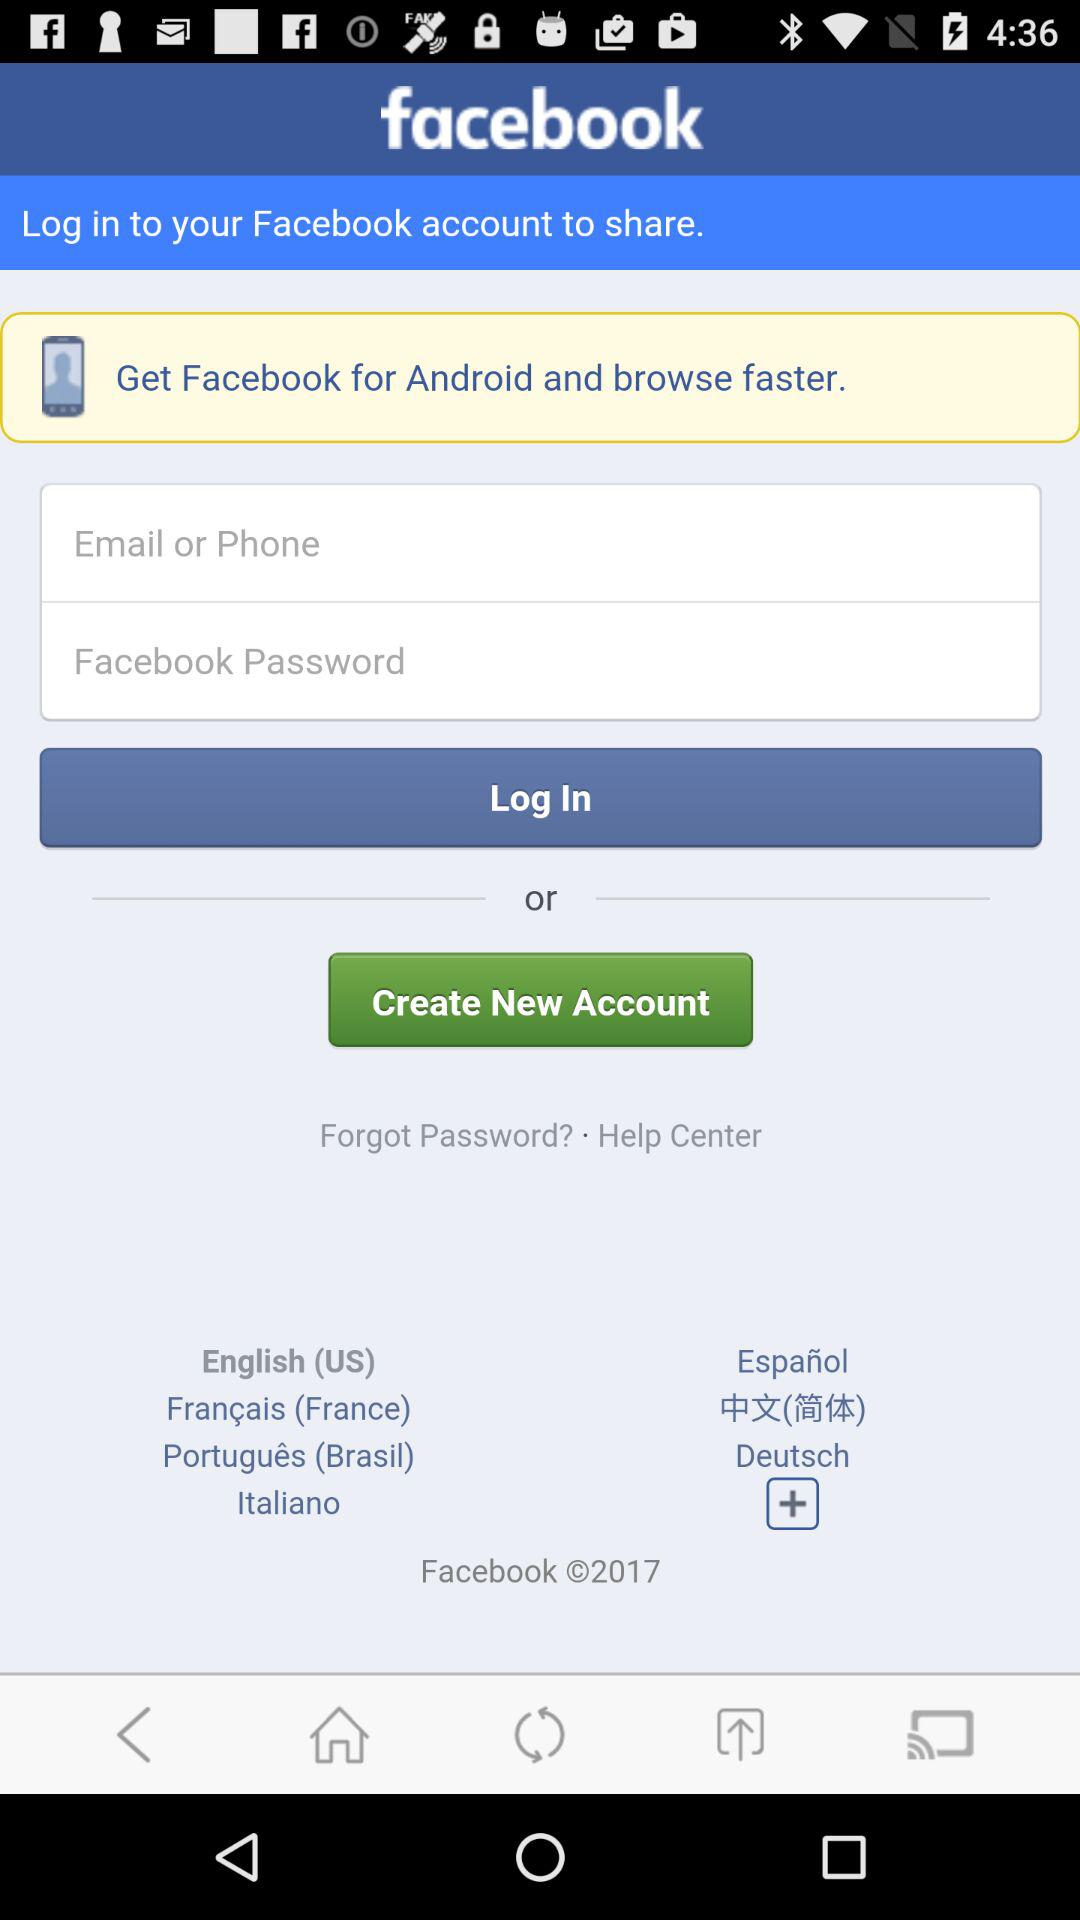In what applications can we log in to share? You can log in to your "Facebook" account. 